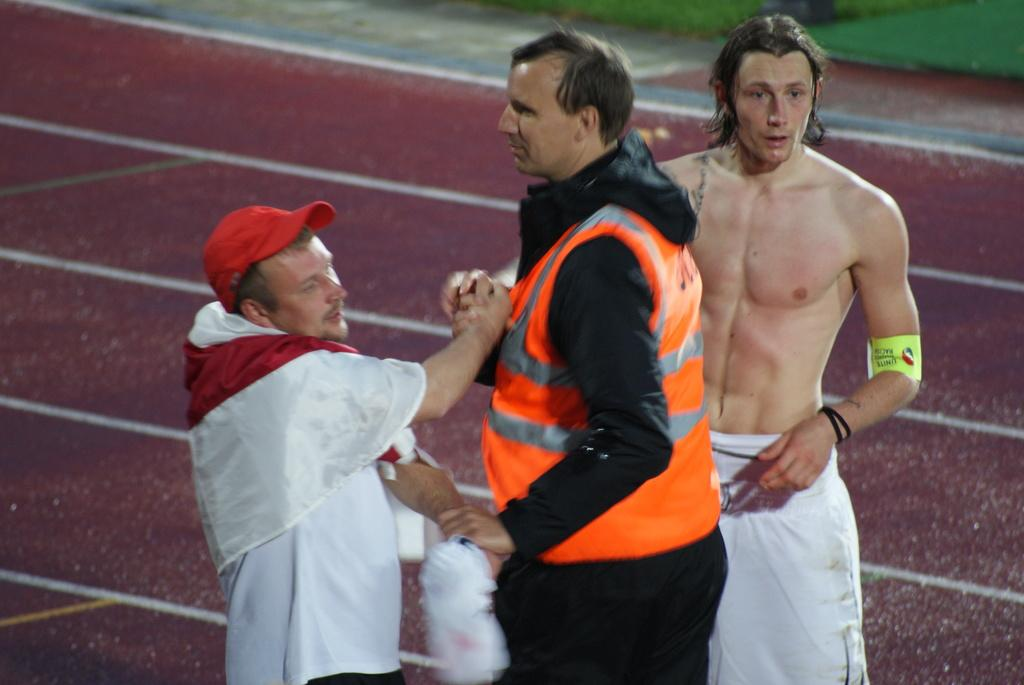What are the people in the image doing? The people in the image are standing and watching something. What can be seen in the background of the image? There is grass visible at the top of the image. What type of plastic is being used by the ants in the image? There are no ants or plastic present in the image. 